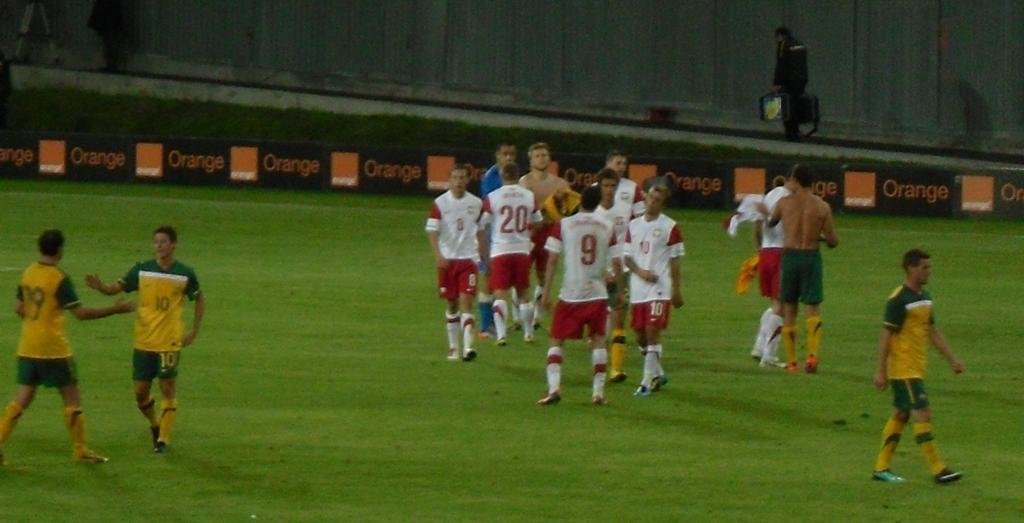Please provide a concise description of this image. There are groups of people standing and few people walking. This looks like a hoarding. I think this is the football ground. Here is a person holding the objects and walking. This looks like a wall. 